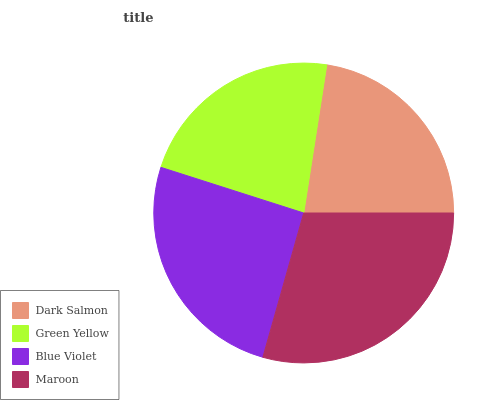Is Green Yellow the minimum?
Answer yes or no. Yes. Is Maroon the maximum?
Answer yes or no. Yes. Is Blue Violet the minimum?
Answer yes or no. No. Is Blue Violet the maximum?
Answer yes or no. No. Is Blue Violet greater than Green Yellow?
Answer yes or no. Yes. Is Green Yellow less than Blue Violet?
Answer yes or no. Yes. Is Green Yellow greater than Blue Violet?
Answer yes or no. No. Is Blue Violet less than Green Yellow?
Answer yes or no. No. Is Blue Violet the high median?
Answer yes or no. Yes. Is Dark Salmon the low median?
Answer yes or no. Yes. Is Maroon the high median?
Answer yes or no. No. Is Green Yellow the low median?
Answer yes or no. No. 